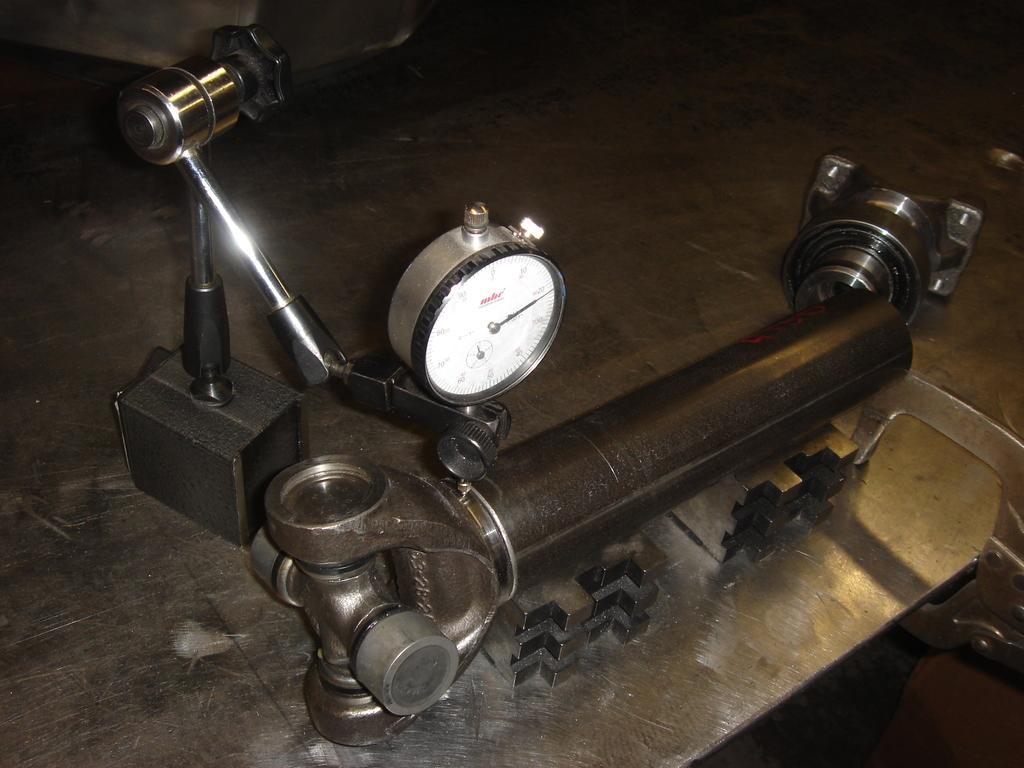In one or two sentences, can you explain what this image depicts? In this image we can see a machine tool placed on the table. 